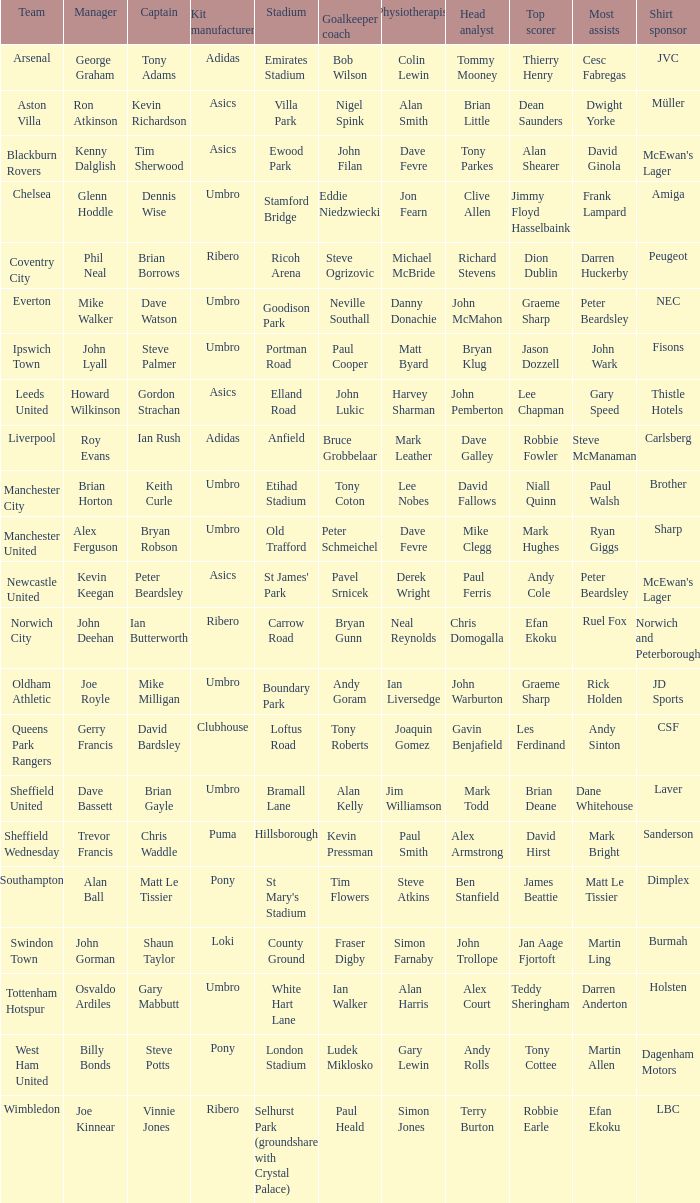Which captain has billy bonds as the manager? Steve Potts. 